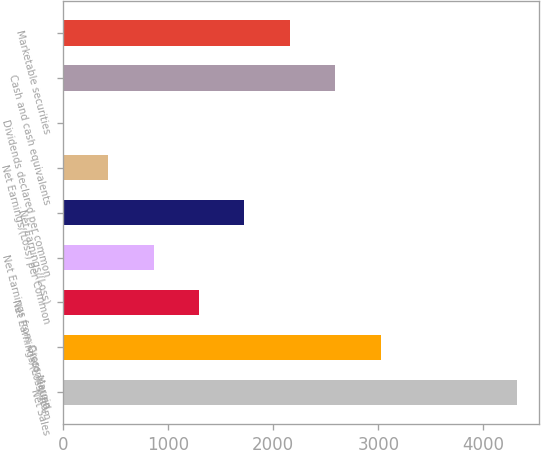<chart> <loc_0><loc_0><loc_500><loc_500><bar_chart><fcel>Net Sales<fcel>Gross Margin<fcel>Net Earnings/(Loss) from<fcel>Net Earnings from Discontinued<fcel>Net Earnings/(Loss)<fcel>Net Earnings/(Loss) per Common<fcel>Dividends declared per common<fcel>Cash and cash equivalents<fcel>Marketable securities<nl><fcel>4317<fcel>3021.97<fcel>1295.29<fcel>863.62<fcel>1726.96<fcel>431.95<fcel>0.28<fcel>2590.3<fcel>2158.63<nl></chart> 